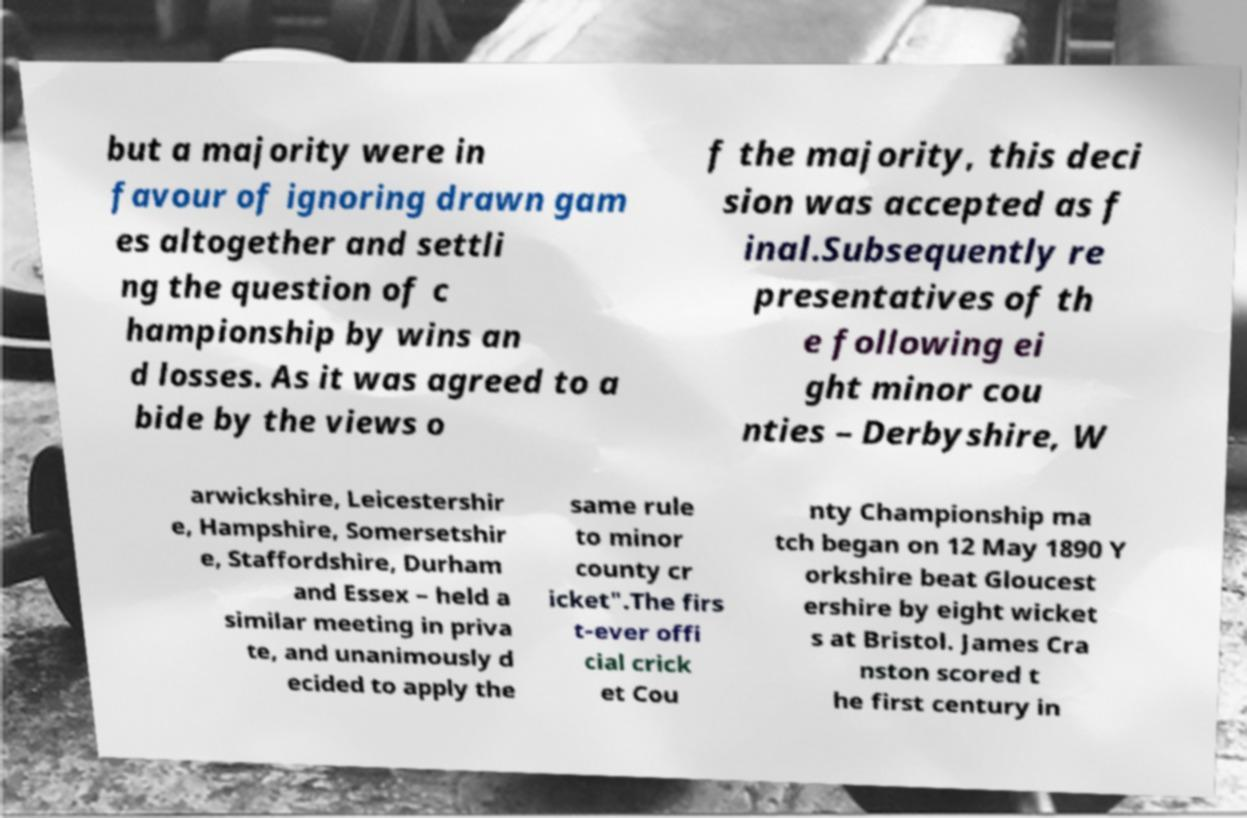Can you read and provide the text displayed in the image?This photo seems to have some interesting text. Can you extract and type it out for me? but a majority were in favour of ignoring drawn gam es altogether and settli ng the question of c hampionship by wins an d losses. As it was agreed to a bide by the views o f the majority, this deci sion was accepted as f inal.Subsequently re presentatives of th e following ei ght minor cou nties – Derbyshire, W arwickshire, Leicestershir e, Hampshire, Somersetshir e, Staffordshire, Durham and Essex – held a similar meeting in priva te, and unanimously d ecided to apply the same rule to minor county cr icket".The firs t-ever offi cial crick et Cou nty Championship ma tch began on 12 May 1890 Y orkshire beat Gloucest ershire by eight wicket s at Bristol. James Cra nston scored t he first century in 